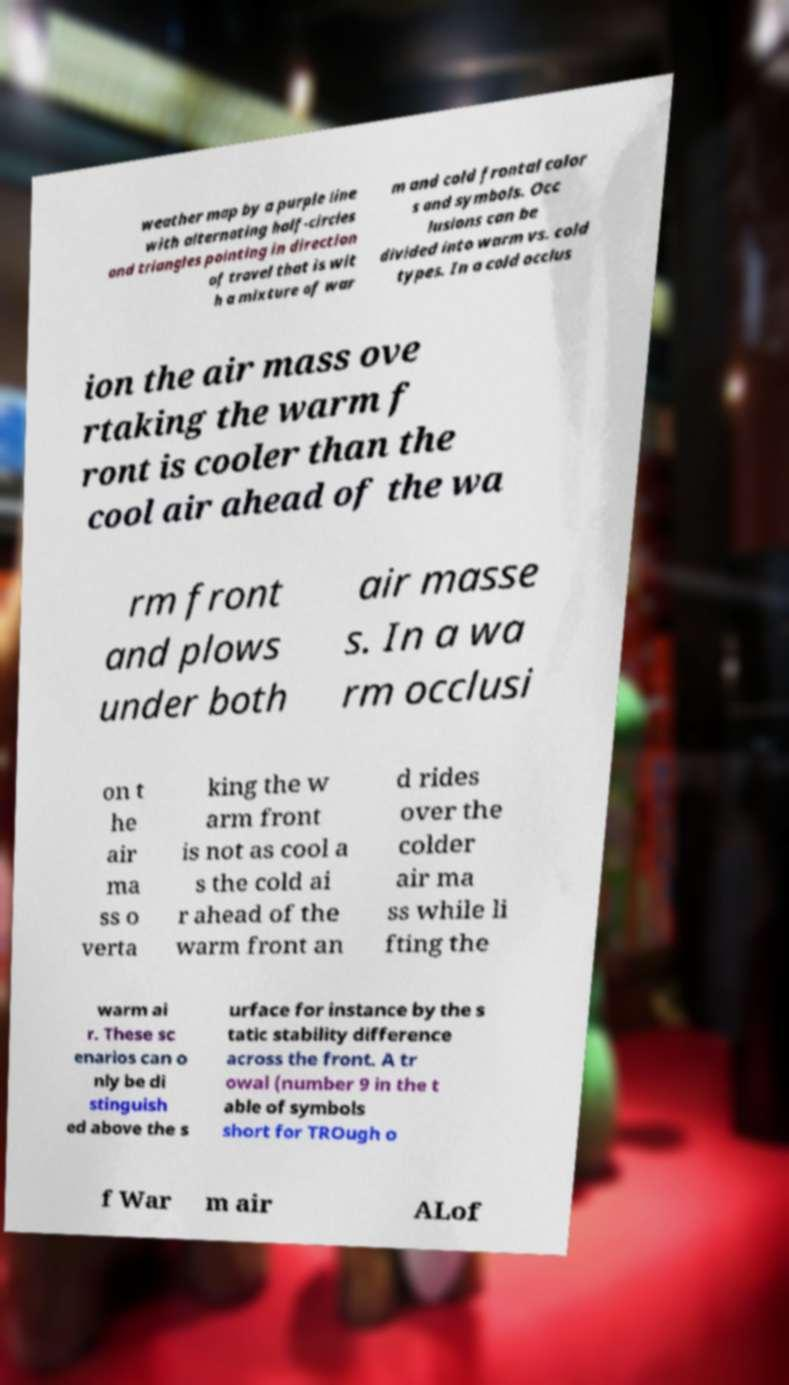Could you assist in decoding the text presented in this image and type it out clearly? weather map by a purple line with alternating half-circles and triangles pointing in direction of travel that is wit h a mixture of war m and cold frontal color s and symbols. Occ lusions can be divided into warm vs. cold types. In a cold occlus ion the air mass ove rtaking the warm f ront is cooler than the cool air ahead of the wa rm front and plows under both air masse s. In a wa rm occlusi on t he air ma ss o verta king the w arm front is not as cool a s the cold ai r ahead of the warm front an d rides over the colder air ma ss while li fting the warm ai r. These sc enarios can o nly be di stinguish ed above the s urface for instance by the s tatic stability difference across the front. A tr owal (number 9 in the t able of symbols short for TROugh o f War m air ALof 